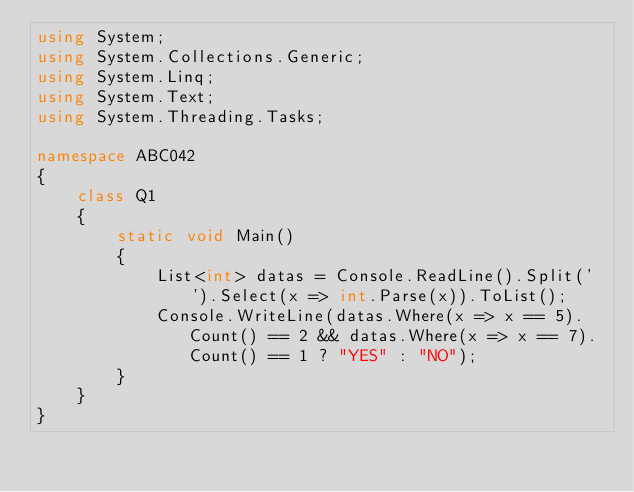<code> <loc_0><loc_0><loc_500><loc_500><_C#_>using System;
using System.Collections.Generic;
using System.Linq;
using System.Text;
using System.Threading.Tasks;

namespace ABC042
{
	class Q1
	{
		static void Main()
		{
			List<int> datas = Console.ReadLine().Split(' ').Select(x => int.Parse(x)).ToList();
			Console.WriteLine(datas.Where(x => x == 5).Count() == 2 && datas.Where(x => x == 7).Count() == 1 ? "YES" : "NO");
		}
	}
}
</code> 